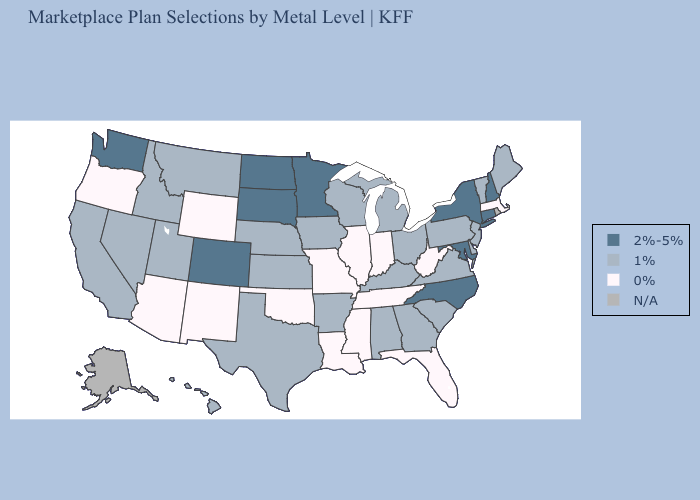What is the lowest value in the Northeast?
Answer briefly. 0%. Name the states that have a value in the range N/A?
Be succinct. Alaska, Rhode Island. What is the lowest value in states that border Idaho?
Be succinct. 0%. Name the states that have a value in the range 1%?
Write a very short answer. Alabama, Arkansas, California, Delaware, Georgia, Hawaii, Idaho, Iowa, Kansas, Kentucky, Maine, Michigan, Montana, Nebraska, Nevada, New Jersey, Ohio, Pennsylvania, South Carolina, Texas, Utah, Vermont, Virginia, Wisconsin. Name the states that have a value in the range N/A?
Write a very short answer. Alaska, Rhode Island. Does California have the lowest value in the West?
Keep it brief. No. Name the states that have a value in the range 1%?
Short answer required. Alabama, Arkansas, California, Delaware, Georgia, Hawaii, Idaho, Iowa, Kansas, Kentucky, Maine, Michigan, Montana, Nebraska, Nevada, New Jersey, Ohio, Pennsylvania, South Carolina, Texas, Utah, Vermont, Virginia, Wisconsin. Among the states that border New Jersey , which have the lowest value?
Keep it brief. Delaware, Pennsylvania. What is the lowest value in the South?
Quick response, please. 0%. What is the value of Hawaii?
Quick response, please. 1%. What is the lowest value in the USA?
Quick response, please. 0%. Name the states that have a value in the range N/A?
Write a very short answer. Alaska, Rhode Island. Name the states that have a value in the range N/A?
Answer briefly. Alaska, Rhode Island. What is the value of California?
Concise answer only. 1%. 